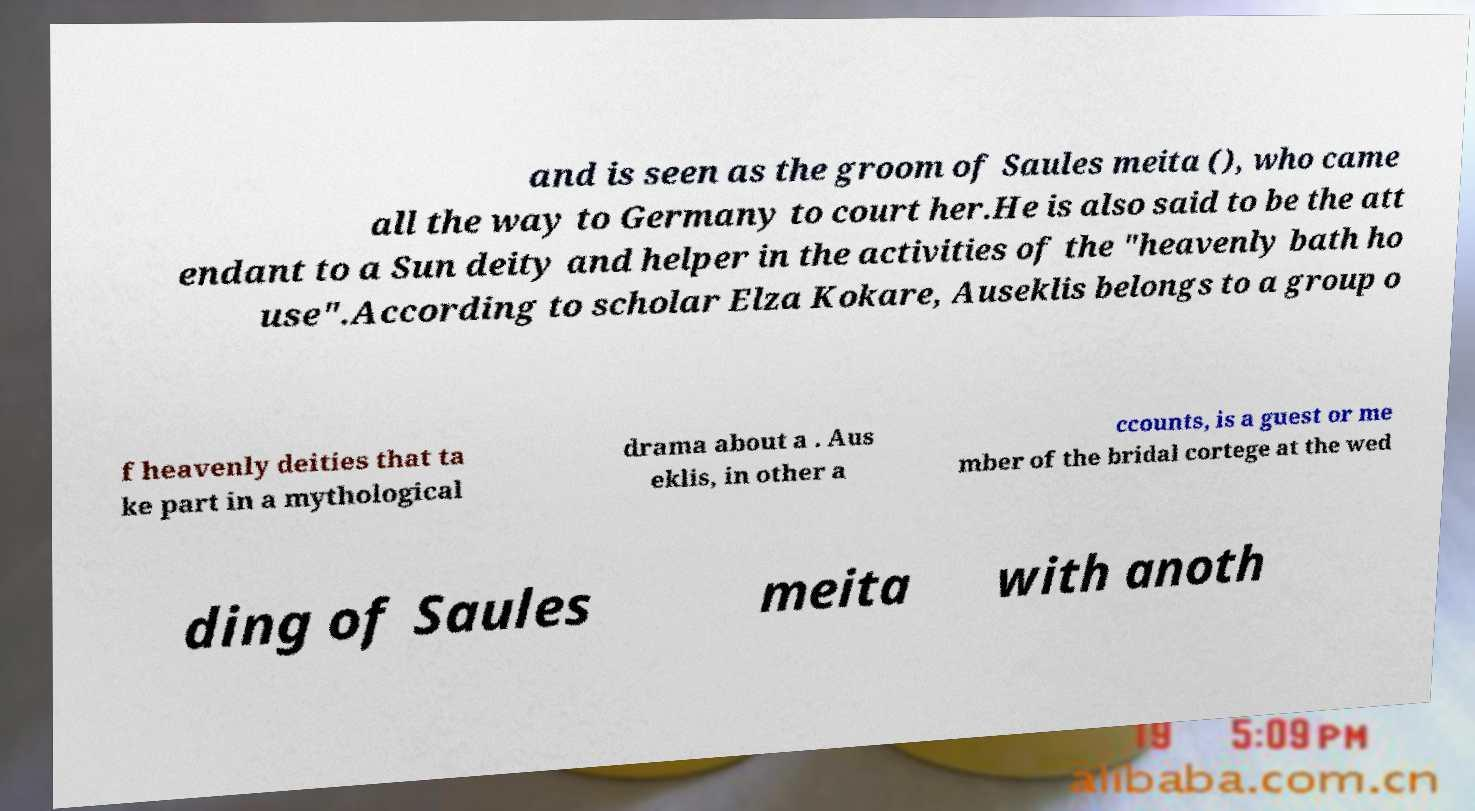Please identify and transcribe the text found in this image. and is seen as the groom of Saules meita (), who came all the way to Germany to court her.He is also said to be the att endant to a Sun deity and helper in the activities of the "heavenly bath ho use".According to scholar Elza Kokare, Auseklis belongs to a group o f heavenly deities that ta ke part in a mythological drama about a . Aus eklis, in other a ccounts, is a guest or me mber of the bridal cortege at the wed ding of Saules meita with anoth 